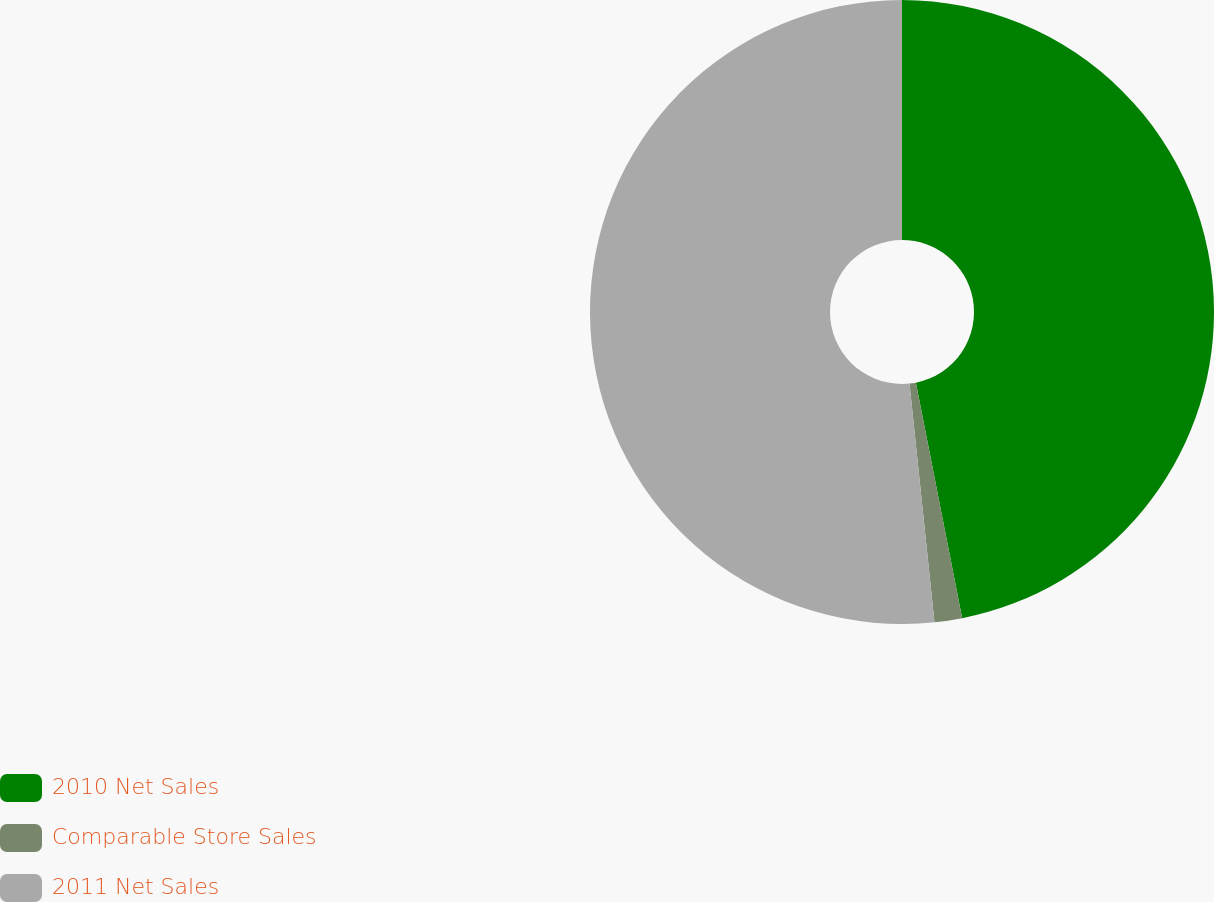<chart> <loc_0><loc_0><loc_500><loc_500><pie_chart><fcel>2010 Net Sales<fcel>Comparable Store Sales<fcel>2011 Net Sales<nl><fcel>46.91%<fcel>1.43%<fcel>51.66%<nl></chart> 